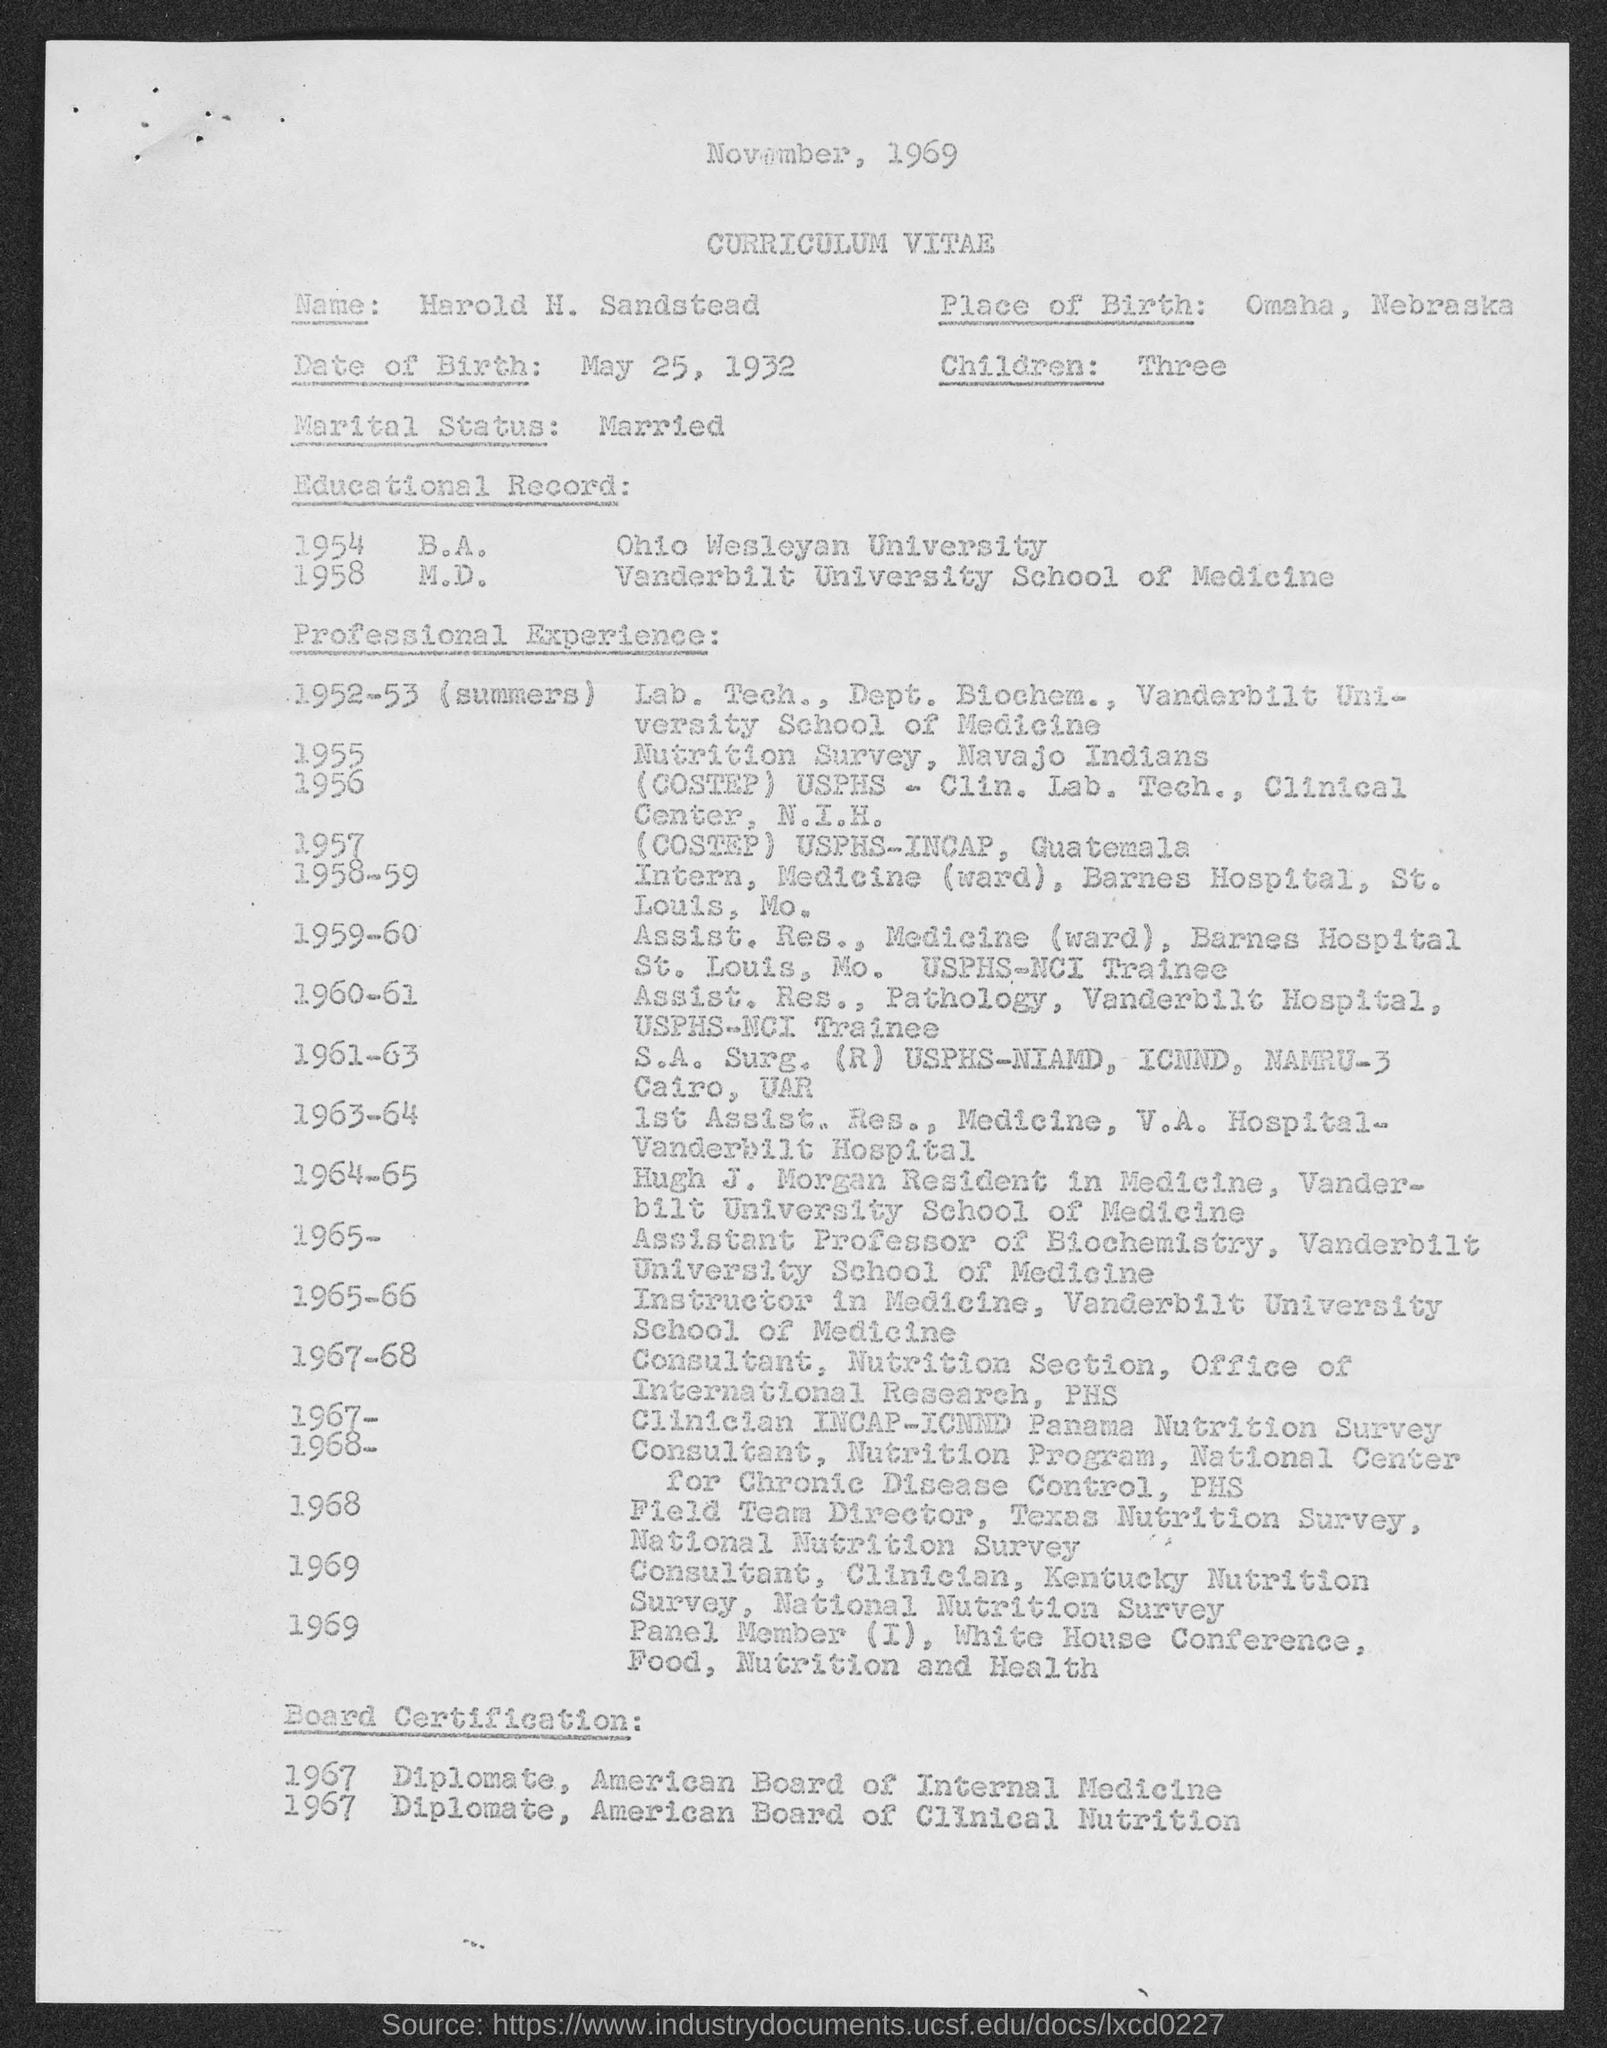What is the place of birth mentioned in the given page ?
Make the answer very short. Omaha, Nebraska. What is the date of birth mentioned in the given page ?
Make the answer very short. May 25, 1932. What is the marital status mentioned in the given page ?
Ensure brevity in your answer.  Married. What is the number of children mentioned in the given page ?
Provide a short and direct response. Three. What is the date mentioned at the top of the page ?
Keep it short and to the point. November, 1969. From which university he completed b.a. ?
Make the answer very short. Ohio Wesleyan University. From which university he completed m.d. as mentioned in the given page ?
Provide a succinct answer. Vanderbilt University School of Medicine. 